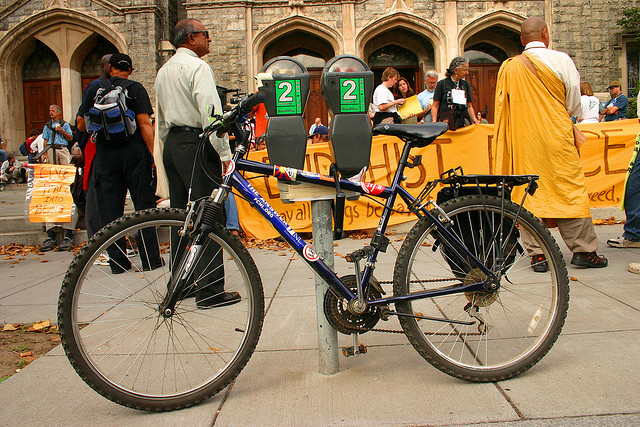Please transcribe the text information in this image. 2 2 all 